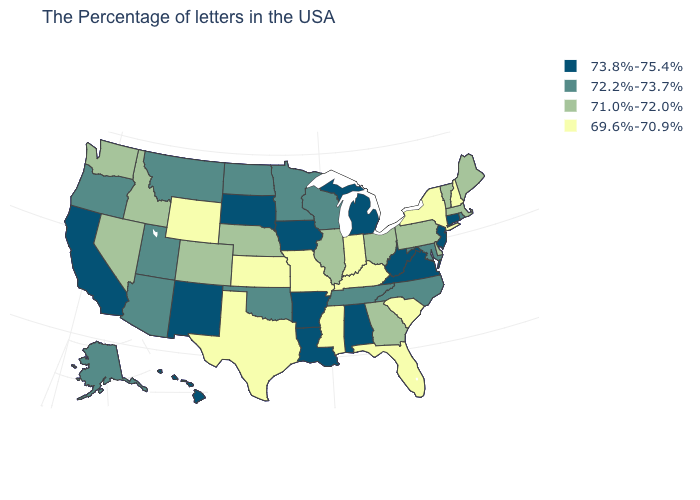What is the value of Michigan?
Quick response, please. 73.8%-75.4%. Which states have the highest value in the USA?
Short answer required. Connecticut, New Jersey, Virginia, West Virginia, Michigan, Alabama, Louisiana, Arkansas, Iowa, South Dakota, New Mexico, California, Hawaii. What is the value of Maryland?
Quick response, please. 72.2%-73.7%. Which states have the lowest value in the South?
Short answer required. South Carolina, Florida, Kentucky, Mississippi, Texas. Among the states that border North Carolina , which have the highest value?
Answer briefly. Virginia. Does Delaware have the lowest value in the USA?
Keep it brief. No. Name the states that have a value in the range 71.0%-72.0%?
Be succinct. Maine, Massachusetts, Vermont, Delaware, Pennsylvania, Ohio, Georgia, Illinois, Nebraska, Colorado, Idaho, Nevada, Washington. Is the legend a continuous bar?
Keep it brief. No. Which states have the lowest value in the USA?
Quick response, please. New Hampshire, New York, South Carolina, Florida, Kentucky, Indiana, Mississippi, Missouri, Kansas, Texas, Wyoming. What is the value of Wisconsin?
Give a very brief answer. 72.2%-73.7%. Name the states that have a value in the range 69.6%-70.9%?
Give a very brief answer. New Hampshire, New York, South Carolina, Florida, Kentucky, Indiana, Mississippi, Missouri, Kansas, Texas, Wyoming. Does the first symbol in the legend represent the smallest category?
Concise answer only. No. Which states hav the highest value in the West?
Keep it brief. New Mexico, California, Hawaii. Which states have the highest value in the USA?
Concise answer only. Connecticut, New Jersey, Virginia, West Virginia, Michigan, Alabama, Louisiana, Arkansas, Iowa, South Dakota, New Mexico, California, Hawaii. What is the lowest value in the USA?
Be succinct. 69.6%-70.9%. 